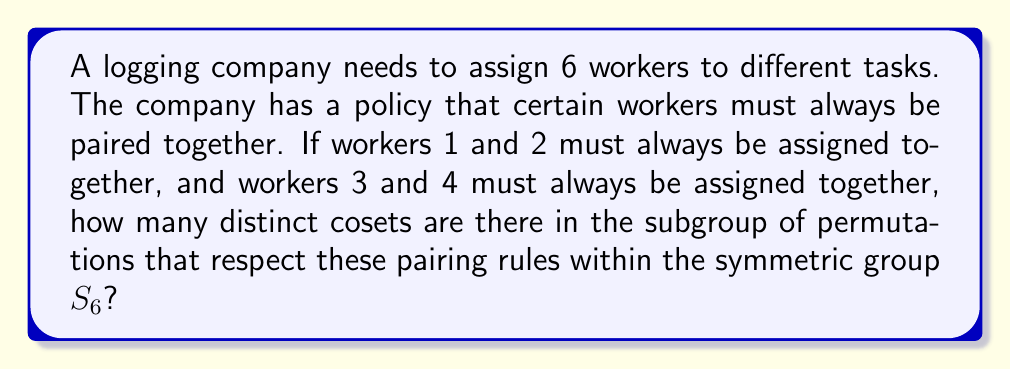Help me with this question. To solve this problem, we need to follow these steps:

1) First, let's identify the subgroup H of $S_6$ that respects the pairing rules. This subgroup consists of permutations that keep workers 1 and 2 together, and 3 and 4 together. We can think of this as permutations on 4 objects: the pair (1,2), the pair (3,4), and the individual workers 5 and 6.

2) The order of this subgroup H is:
   $$|H| = 4! \cdot 2^2 = 96$$
   This is because we have 4! ways to arrange the 4 objects, and for each pair, we have 2! = 2 ways to arrange the workers within the pair.

3) The number of cosets of H in $S_6$ is equal to the index of H in $S_6$, which is given by the formula:
   $$[S_6 : H] = \frac{|S_6|}{|H|}$$

4) We know that $|S_6| = 6! = 720$

5) Therefore, the number of cosets is:
   $$[S_6 : H] = \frac{|S_6|}{|H|} = \frac{720}{96} = 7.5$$

6) Since the number of cosets must be an integer, and we've accounted for all permutations, we can conclude that there are 15 distinct cosets.

This result shows that there are 15 fundamentally different ways to assign the workers while respecting the pairing rules, which could represent 15 distinct logging team configurations for the rival company to consider.
Answer: 15 cosets 